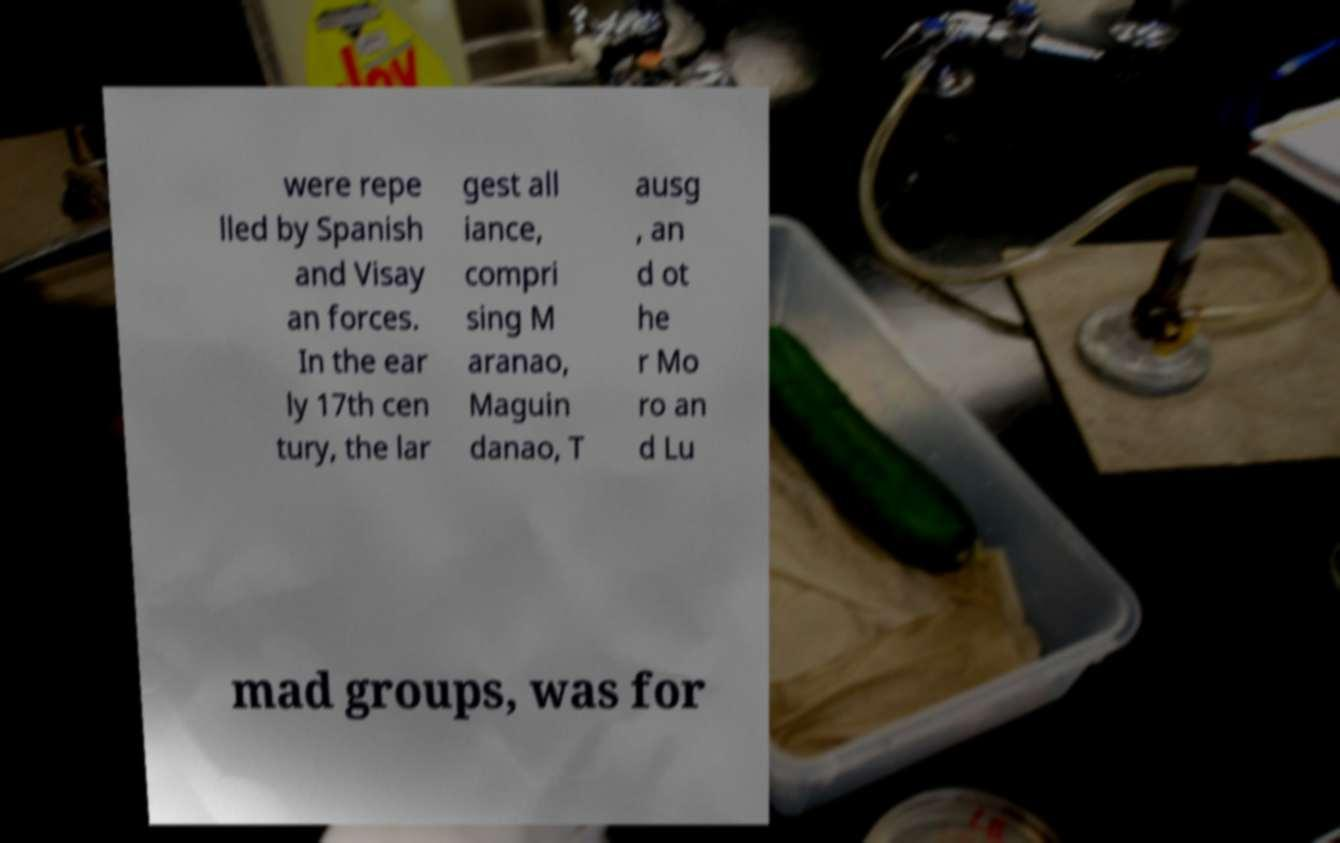Can you read and provide the text displayed in the image?This photo seems to have some interesting text. Can you extract and type it out for me? were repe lled by Spanish and Visay an forces. In the ear ly 17th cen tury, the lar gest all iance, compri sing M aranao, Maguin danao, T ausg , an d ot he r Mo ro an d Lu mad groups, was for 